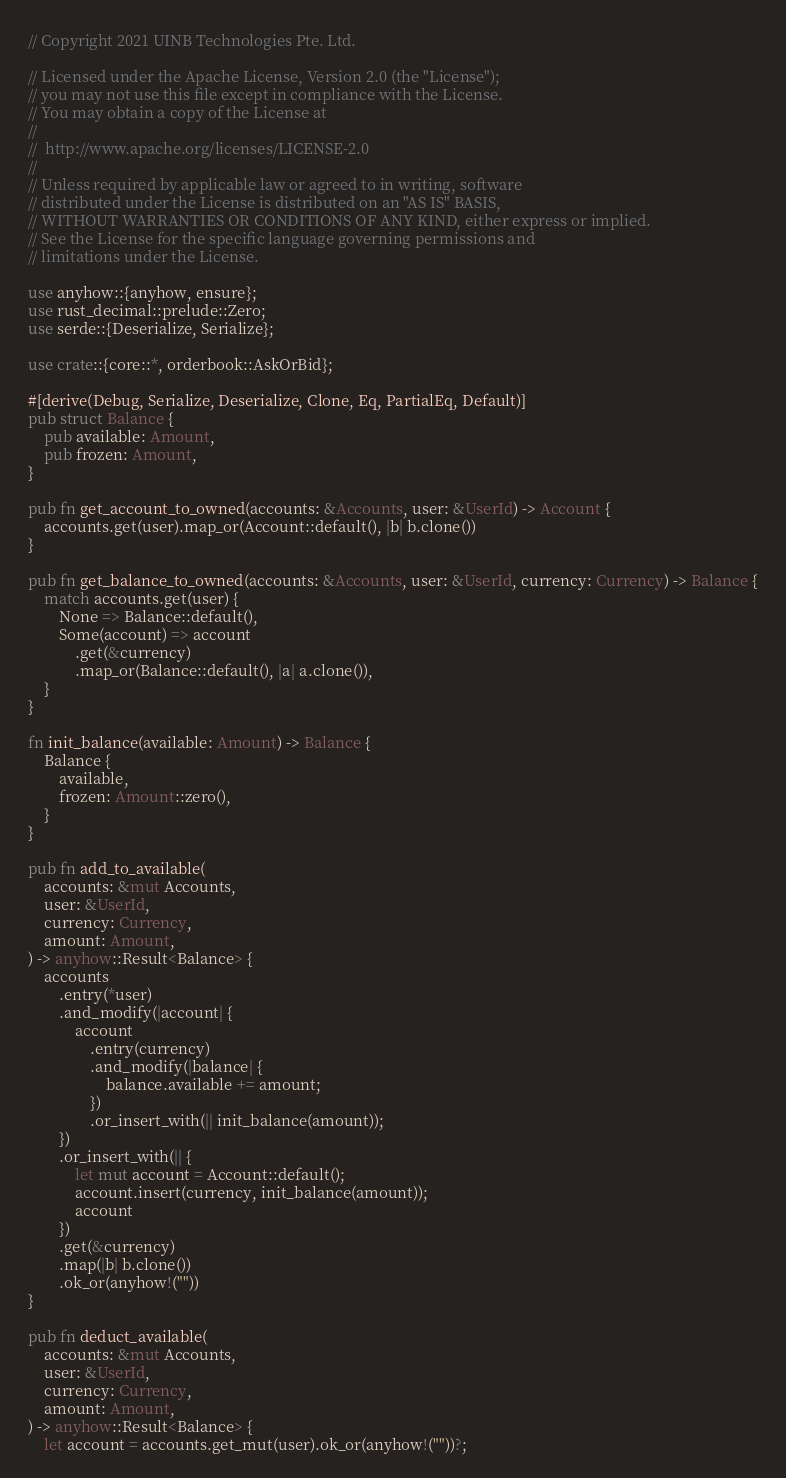<code> <loc_0><loc_0><loc_500><loc_500><_Rust_>// Copyright 2021 UINB Technologies Pte. Ltd.

// Licensed under the Apache License, Version 2.0 (the "License");
// you may not use this file except in compliance with the License.
// You may obtain a copy of the License at
//
// 	http://www.apache.org/licenses/LICENSE-2.0
//
// Unless required by applicable law or agreed to in writing, software
// distributed under the License is distributed on an "AS IS" BASIS,
// WITHOUT WARRANTIES OR CONDITIONS OF ANY KIND, either express or implied.
// See the License for the specific language governing permissions and
// limitations under the License.

use anyhow::{anyhow, ensure};
use rust_decimal::prelude::Zero;
use serde::{Deserialize, Serialize};

use crate::{core::*, orderbook::AskOrBid};

#[derive(Debug, Serialize, Deserialize, Clone, Eq, PartialEq, Default)]
pub struct Balance {
    pub available: Amount,
    pub frozen: Amount,
}

pub fn get_account_to_owned(accounts: &Accounts, user: &UserId) -> Account {
    accounts.get(user).map_or(Account::default(), |b| b.clone())
}

pub fn get_balance_to_owned(accounts: &Accounts, user: &UserId, currency: Currency) -> Balance {
    match accounts.get(user) {
        None => Balance::default(),
        Some(account) => account
            .get(&currency)
            .map_or(Balance::default(), |a| a.clone()),
    }
}

fn init_balance(available: Amount) -> Balance {
    Balance {
        available,
        frozen: Amount::zero(),
    }
}

pub fn add_to_available(
    accounts: &mut Accounts,
    user: &UserId,
    currency: Currency,
    amount: Amount,
) -> anyhow::Result<Balance> {
    accounts
        .entry(*user)
        .and_modify(|account| {
            account
                .entry(currency)
                .and_modify(|balance| {
                    balance.available += amount;
                })
                .or_insert_with(|| init_balance(amount));
        })
        .or_insert_with(|| {
            let mut account = Account::default();
            account.insert(currency, init_balance(amount));
            account
        })
        .get(&currency)
        .map(|b| b.clone())
        .ok_or(anyhow!(""))
}

pub fn deduct_available(
    accounts: &mut Accounts,
    user: &UserId,
    currency: Currency,
    amount: Amount,
) -> anyhow::Result<Balance> {
    let account = accounts.get_mut(user).ok_or(anyhow!(""))?;</code> 